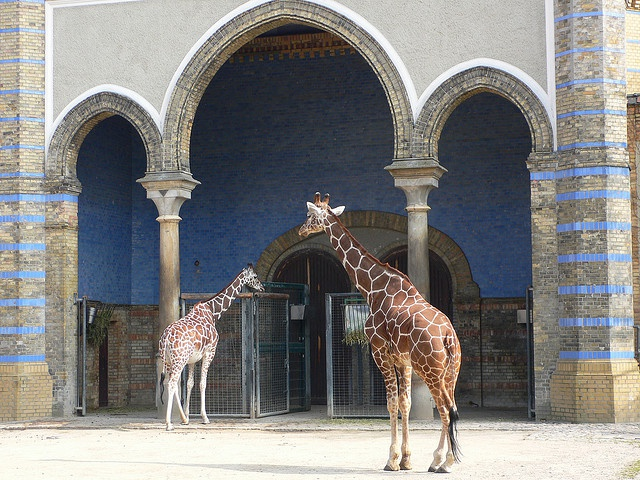Describe the objects in this image and their specific colors. I can see giraffe in darkgray, ivory, maroon, and gray tones and giraffe in darkgray, white, gray, and brown tones in this image. 